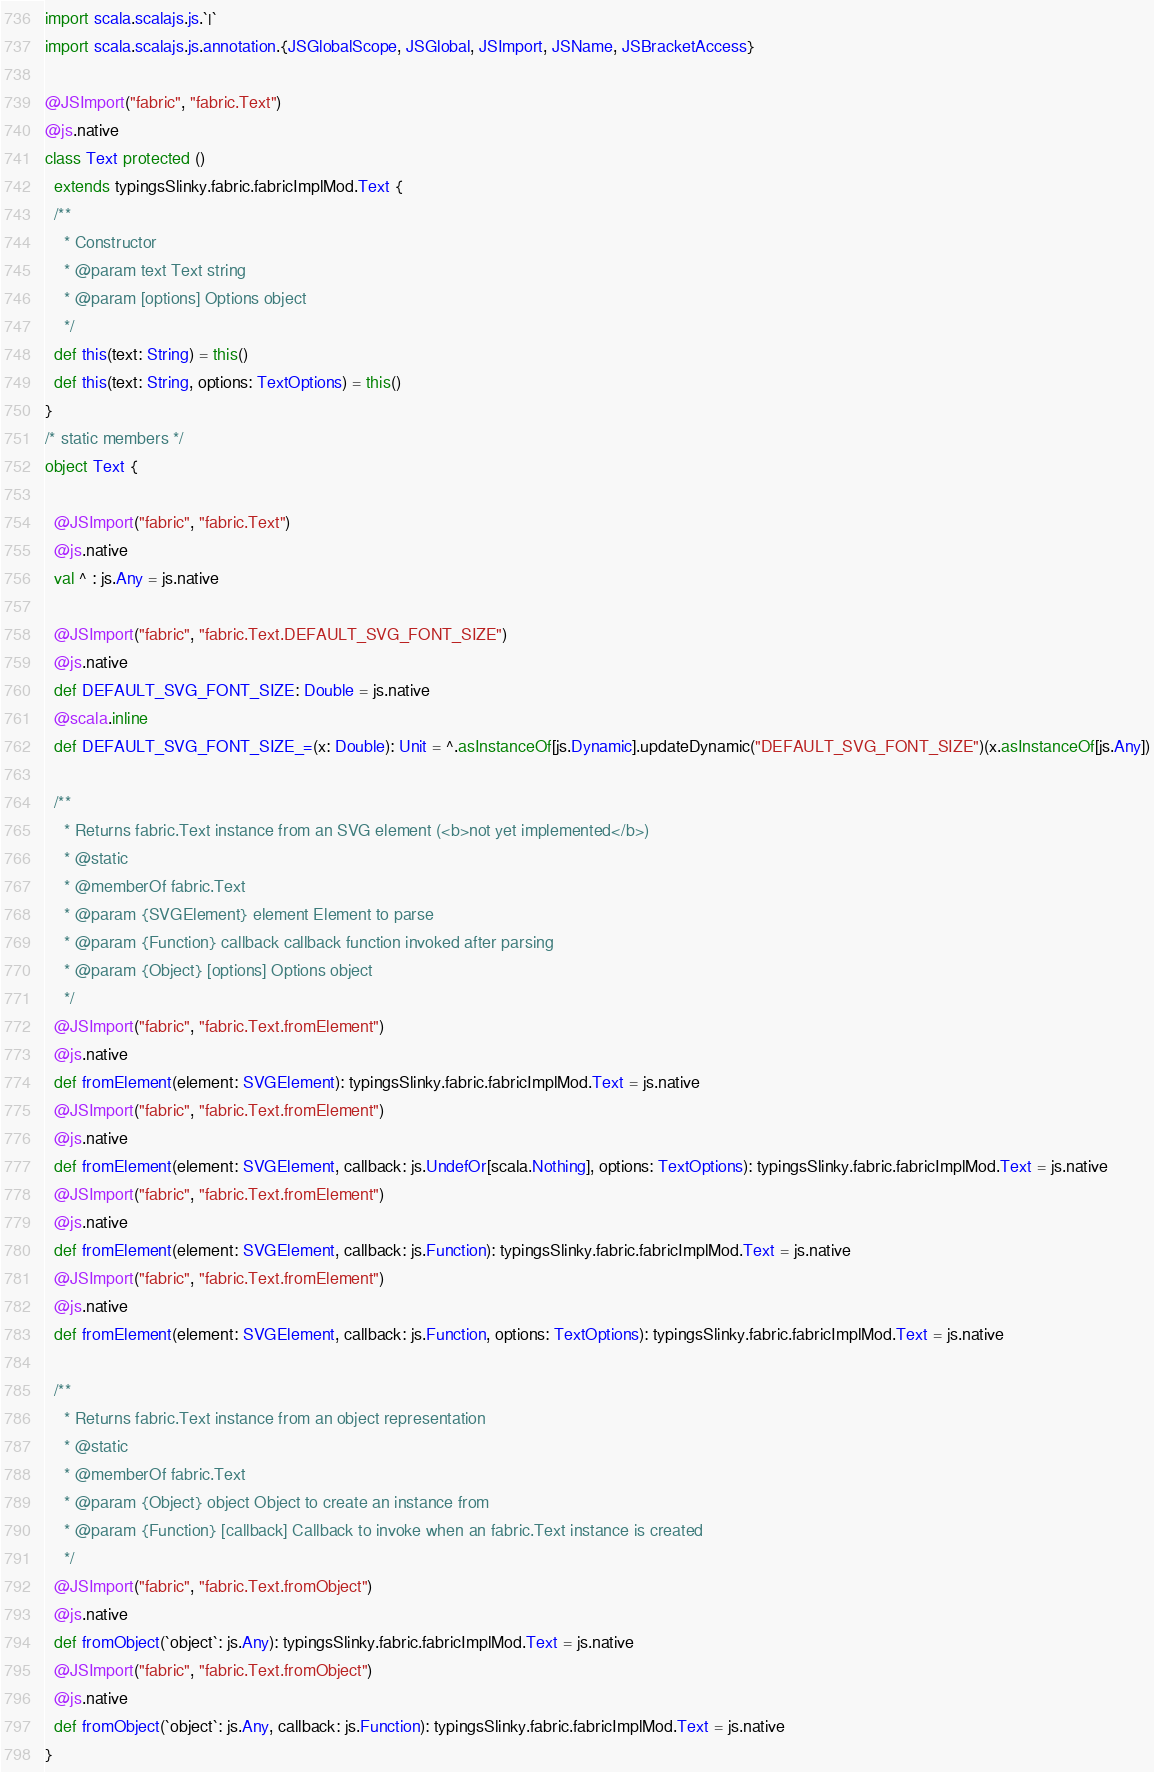<code> <loc_0><loc_0><loc_500><loc_500><_Scala_>import scala.scalajs.js.`|`
import scala.scalajs.js.annotation.{JSGlobalScope, JSGlobal, JSImport, JSName, JSBracketAccess}

@JSImport("fabric", "fabric.Text")
@js.native
class Text protected ()
  extends typingsSlinky.fabric.fabricImplMod.Text {
  /**
    * Constructor
    * @param text Text string
    * @param [options] Options object
    */
  def this(text: String) = this()
  def this(text: String, options: TextOptions) = this()
}
/* static members */
object Text {
  
  @JSImport("fabric", "fabric.Text")
  @js.native
  val ^ : js.Any = js.native
  
  @JSImport("fabric", "fabric.Text.DEFAULT_SVG_FONT_SIZE")
  @js.native
  def DEFAULT_SVG_FONT_SIZE: Double = js.native
  @scala.inline
  def DEFAULT_SVG_FONT_SIZE_=(x: Double): Unit = ^.asInstanceOf[js.Dynamic].updateDynamic("DEFAULT_SVG_FONT_SIZE")(x.asInstanceOf[js.Any])
  
  /**
    * Returns fabric.Text instance from an SVG element (<b>not yet implemented</b>)
    * @static
    * @memberOf fabric.Text
    * @param {SVGElement} element Element to parse
    * @param {Function} callback callback function invoked after parsing
    * @param {Object} [options] Options object
    */
  @JSImport("fabric", "fabric.Text.fromElement")
  @js.native
  def fromElement(element: SVGElement): typingsSlinky.fabric.fabricImplMod.Text = js.native
  @JSImport("fabric", "fabric.Text.fromElement")
  @js.native
  def fromElement(element: SVGElement, callback: js.UndefOr[scala.Nothing], options: TextOptions): typingsSlinky.fabric.fabricImplMod.Text = js.native
  @JSImport("fabric", "fabric.Text.fromElement")
  @js.native
  def fromElement(element: SVGElement, callback: js.Function): typingsSlinky.fabric.fabricImplMod.Text = js.native
  @JSImport("fabric", "fabric.Text.fromElement")
  @js.native
  def fromElement(element: SVGElement, callback: js.Function, options: TextOptions): typingsSlinky.fabric.fabricImplMod.Text = js.native
  
  /**
    * Returns fabric.Text instance from an object representation
    * @static
    * @memberOf fabric.Text
    * @param {Object} object Object to create an instance from
    * @param {Function} [callback] Callback to invoke when an fabric.Text instance is created
    */
  @JSImport("fabric", "fabric.Text.fromObject")
  @js.native
  def fromObject(`object`: js.Any): typingsSlinky.fabric.fabricImplMod.Text = js.native
  @JSImport("fabric", "fabric.Text.fromObject")
  @js.native
  def fromObject(`object`: js.Any, callback: js.Function): typingsSlinky.fabric.fabricImplMod.Text = js.native
}
</code> 